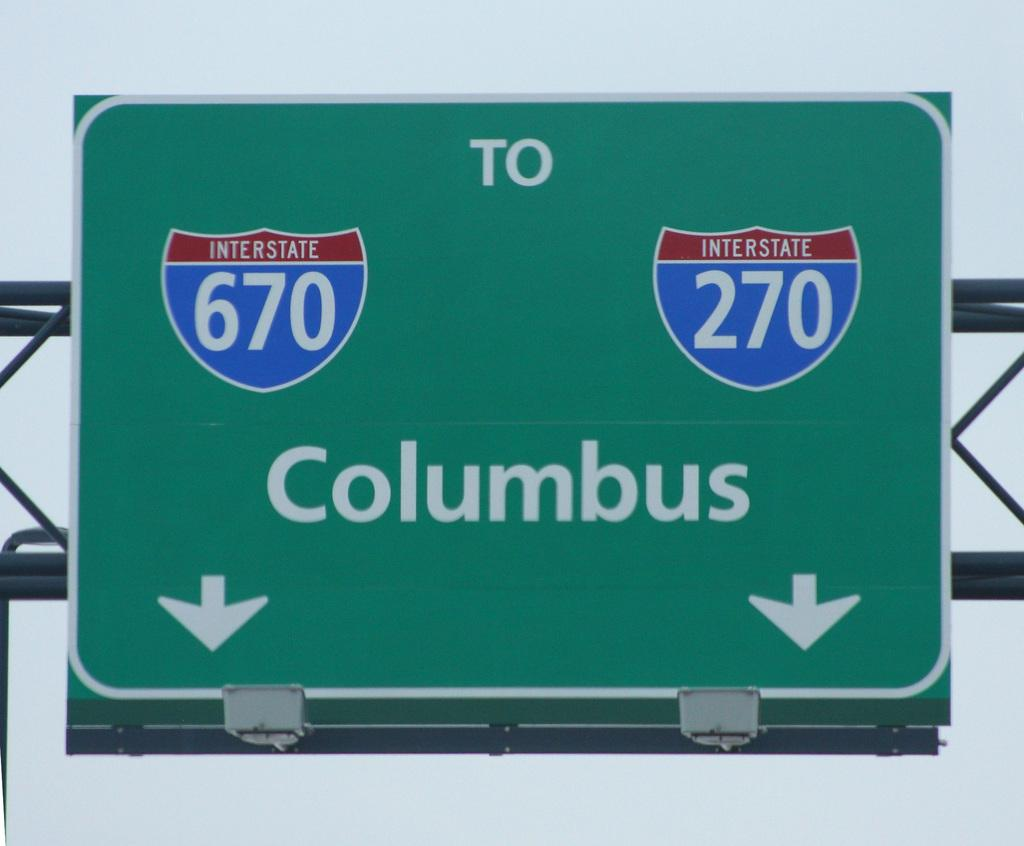What is the color of the signboard in the image? The signboard in the image is green. What information is displayed on the signboard? The signboard has numbers and text written on it. Where is the signboard located? The signboard is placed on a hoarding. How many lizards are sitting on the signboard in the image? There are no lizards present on the signboard in the image. What degree is required to read the text on the signboard in the image? The text on the signboard does not require any specific degree to read. 